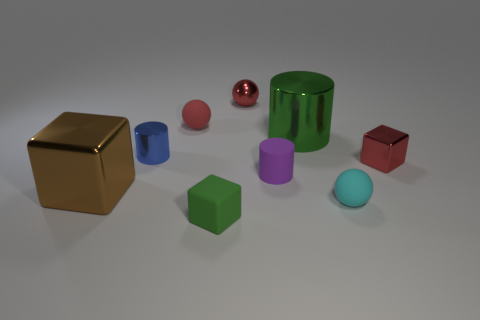There is another shiny thing that is the same size as the brown object; what color is it?
Your response must be concise. Green. There is a small metallic thing that is both in front of the green metal cylinder and to the left of the big cylinder; what is its color?
Ensure brevity in your answer.  Blue. There is a matte thing that is the same color as the small shiny cube; what is its size?
Ensure brevity in your answer.  Small. There is a large object that is the same color as the tiny matte cube; what is its shape?
Your response must be concise. Cylinder. How big is the matte sphere on the left side of the green object that is behind the green object that is in front of the tiny cyan object?
Make the answer very short. Small. What is the material of the large green cylinder?
Offer a terse response. Metal. Do the brown object and the large object on the right side of the small matte cylinder have the same material?
Provide a succinct answer. Yes. Is there anything else of the same color as the small metal sphere?
Give a very brief answer. Yes. There is a rubber thing on the right side of the cylinder in front of the blue metal thing; are there any rubber objects right of it?
Your answer should be compact. No. The small metallic sphere has what color?
Ensure brevity in your answer.  Red. 